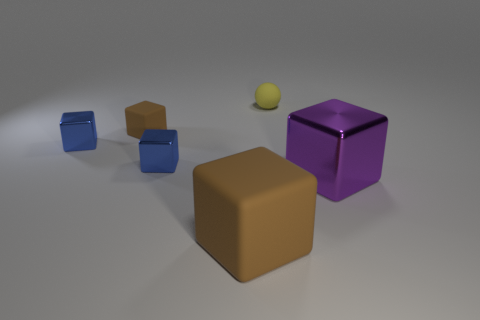What is the shape of the big thing right of the brown matte cube that is in front of the tiny brown matte cube?
Provide a succinct answer. Cube. There is a large cube that is the same material as the small yellow thing; what is its color?
Your answer should be compact. Brown. Does the small ball have the same color as the big shiny cube?
Make the answer very short. No. There is a rubber object that is the same size as the yellow ball; what shape is it?
Offer a very short reply. Cube. What size is the purple metallic cube?
Offer a very short reply. Large. There is a block that is right of the tiny matte ball; does it have the same size as the blue thing right of the small rubber block?
Offer a very short reply. No. There is a matte block that is behind the large cube left of the sphere; what is its color?
Your answer should be compact. Brown. How many matte objects are either tiny blue objects or small yellow blocks?
Provide a succinct answer. 0. What color is the small object that is both in front of the yellow rubber ball and on the right side of the tiny brown cube?
Keep it short and to the point. Blue. There is a yellow ball; what number of things are to the right of it?
Your answer should be very brief. 1. 